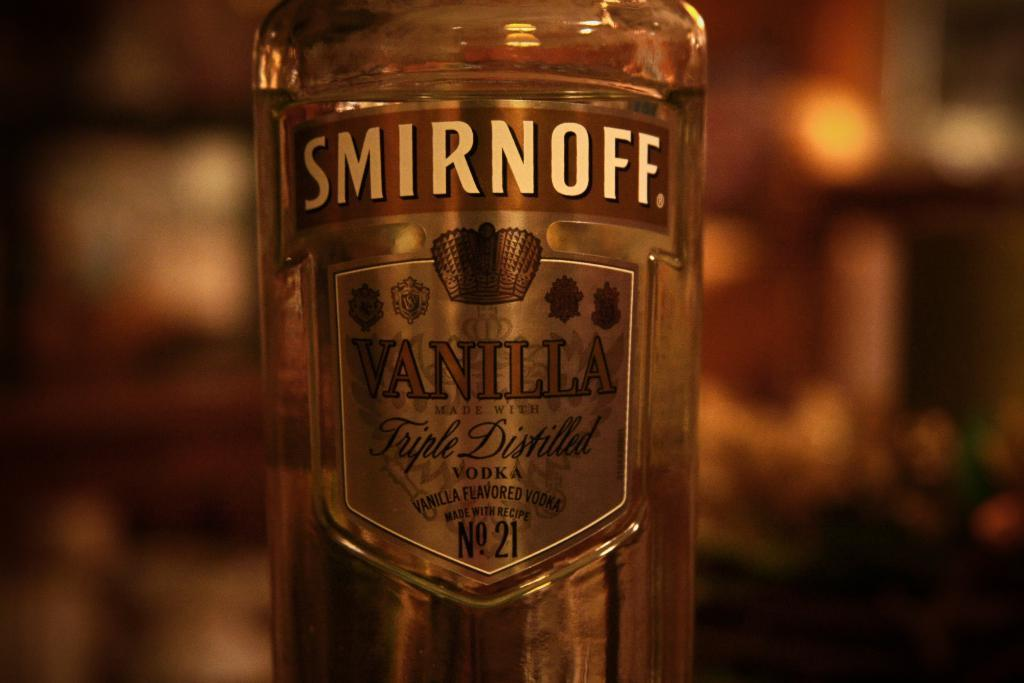<image>
Relay a brief, clear account of the picture shown. A bottle of Smirnoff Vanilla is in a dimly lit room. 